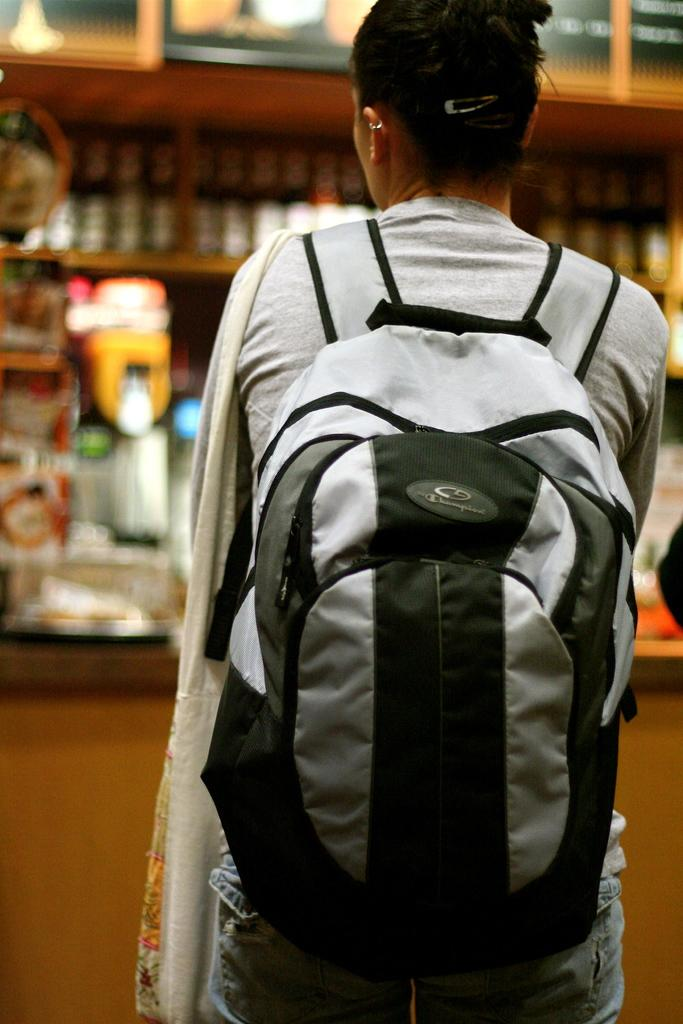What can be seen in the image regarding a person? There is a person in the image, and they are standing with their back facing the viewer. What is the person wearing in the image? The person is wearing a backpack in the image. What is in front of the person in the image? There are cupboards in front of the person in the image. What type of rhythm is the person dancing to in the image? There is no indication in the image that the person is dancing, and therefore no rhythm can be determined. 